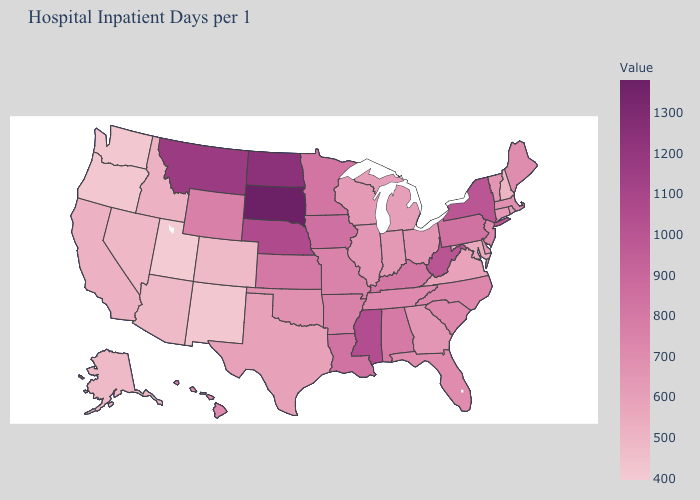Among the states that border Kansas , does Colorado have the lowest value?
Short answer required. Yes. Does New Hampshire have the lowest value in the Northeast?
Keep it brief. Yes. Is the legend a continuous bar?
Concise answer only. Yes. Among the states that border Virginia , does Tennessee have the highest value?
Short answer required. No. 